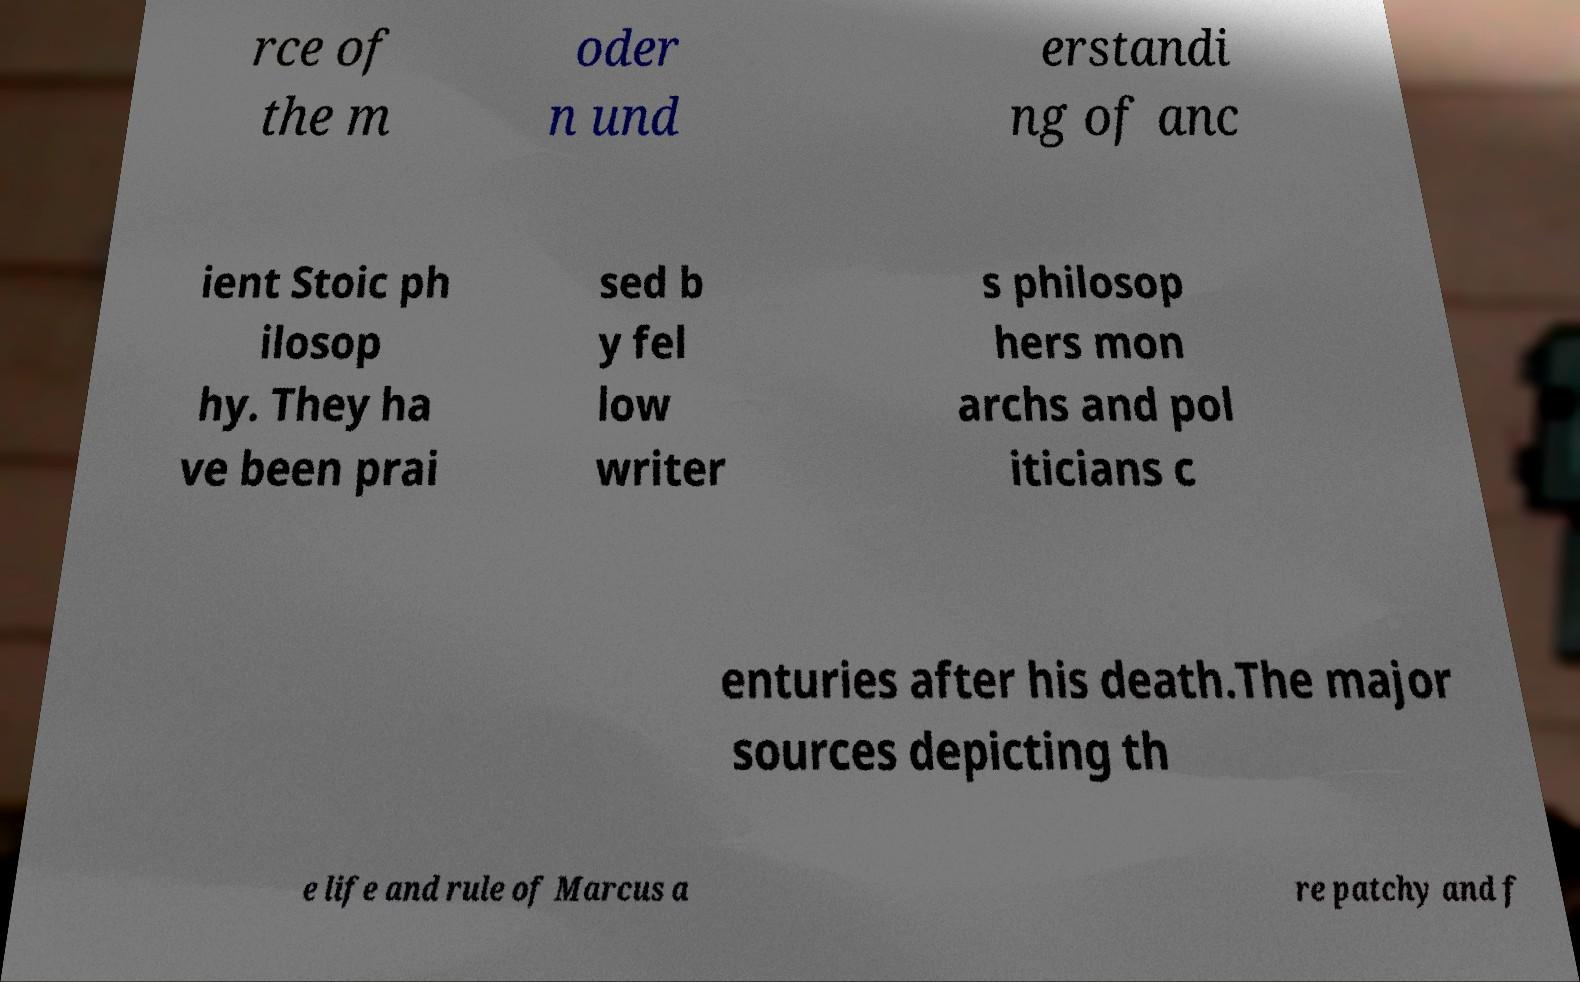Can you read and provide the text displayed in the image?This photo seems to have some interesting text. Can you extract and type it out for me? rce of the m oder n und erstandi ng of anc ient Stoic ph ilosop hy. They ha ve been prai sed b y fel low writer s philosop hers mon archs and pol iticians c enturies after his death.The major sources depicting th e life and rule of Marcus a re patchy and f 